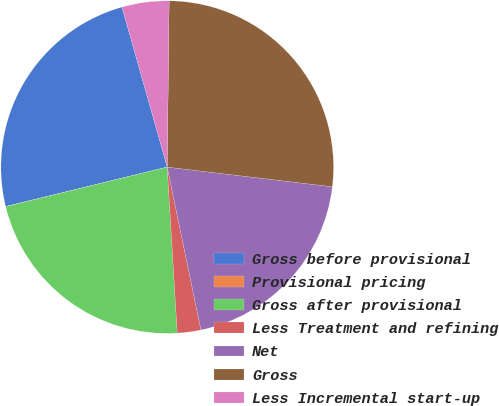Convert chart to OTSL. <chart><loc_0><loc_0><loc_500><loc_500><pie_chart><fcel>Gross before provisional<fcel>Provisional pricing<fcel>Gross after provisional<fcel>Less Treatment and refining<fcel>Net<fcel>Gross<fcel>Less Incremental start-up<nl><fcel>24.42%<fcel>0.01%<fcel>22.14%<fcel>2.29%<fcel>19.86%<fcel>26.7%<fcel>4.57%<nl></chart> 